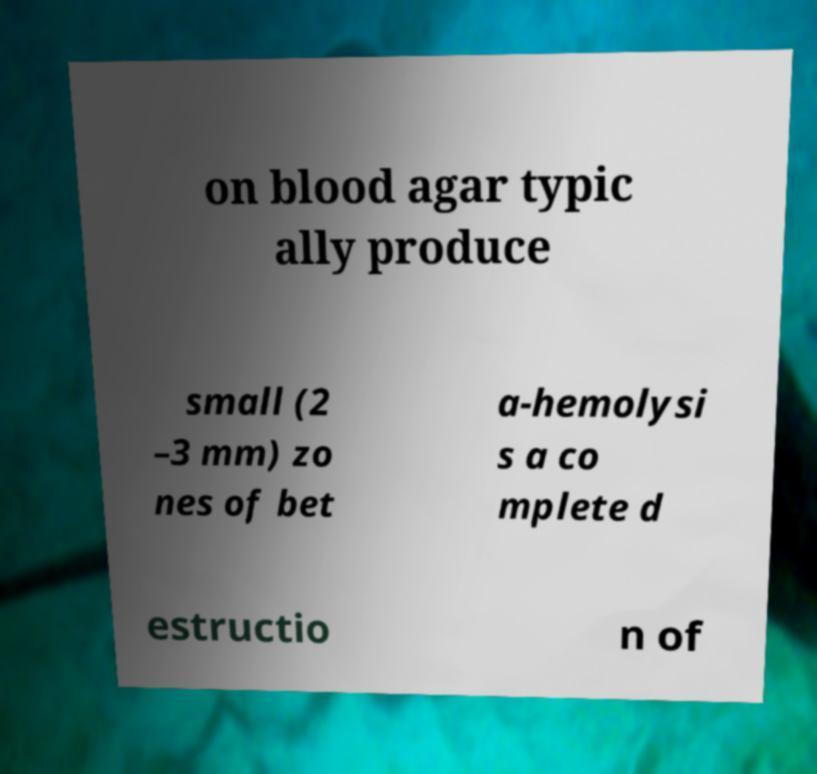There's text embedded in this image that I need extracted. Can you transcribe it verbatim? on blood agar typic ally produce small (2 –3 mm) zo nes of bet a-hemolysi s a co mplete d estructio n of 